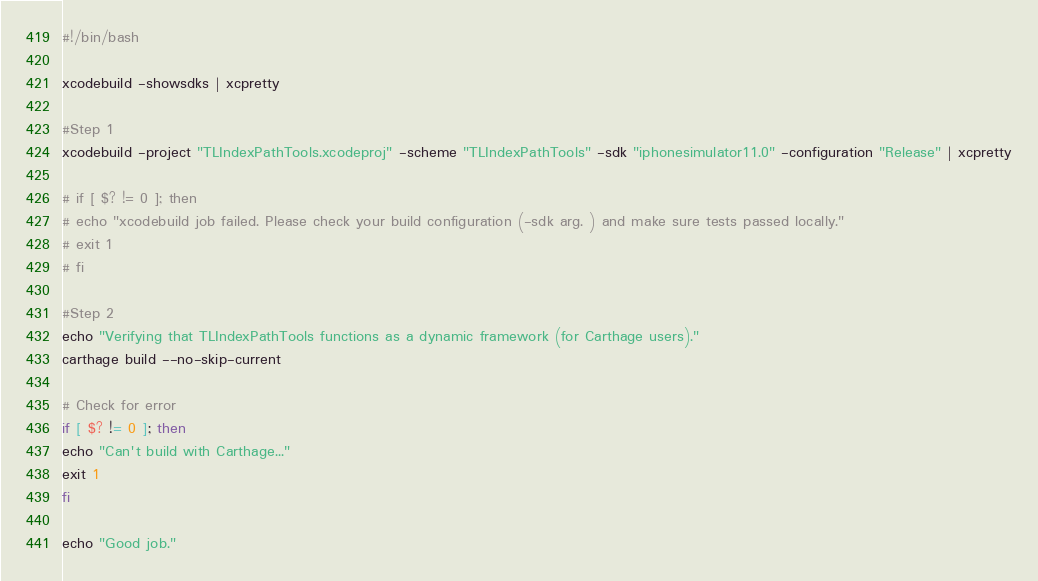Convert code to text. <code><loc_0><loc_0><loc_500><loc_500><_Bash_>#!/bin/bash

xcodebuild -showsdks | xcpretty

#Step 1
xcodebuild -project "TLIndexPathTools.xcodeproj" -scheme "TLIndexPathTools" -sdk "iphonesimulator11.0" -configuration "Release" | xcpretty

# if [ $? != 0 ]; then
# echo "xcodebuild job failed. Please check your build configuration (-sdk arg. ) and make sure tests passed locally."
# exit 1
# fi

#Step 2
echo "Verifying that TLIndexPathTools functions as a dynamic framework (for Carthage users)."
carthage build --no-skip-current

# Check for error
if [ $? != 0 ]; then
echo "Can't build with Carthage..."
exit 1
fi

echo "Good job."
</code> 